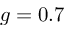Convert formula to latex. <formula><loc_0><loc_0><loc_500><loc_500>g = 0 . 7</formula> 